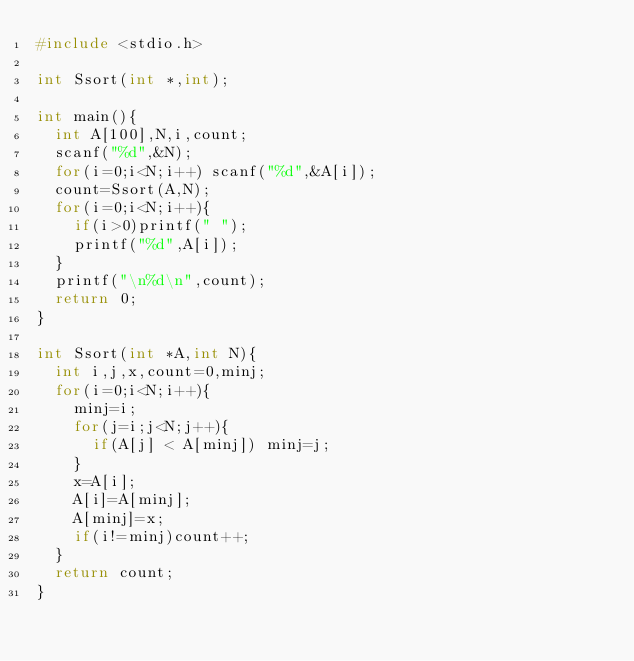Convert code to text. <code><loc_0><loc_0><loc_500><loc_500><_C_>#include <stdio.h>

int Ssort(int *,int);

int main(){
  int A[100],N,i,count;
  scanf("%d",&N);
  for(i=0;i<N;i++) scanf("%d",&A[i]);
  count=Ssort(A,N);
  for(i=0;i<N;i++){
    if(i>0)printf(" ");
    printf("%d",A[i]);
  }
  printf("\n%d\n",count);
  return 0;
}

int Ssort(int *A,int N){
  int i,j,x,count=0,minj;
  for(i=0;i<N;i++){
    minj=i;
    for(j=i;j<N;j++){
      if(A[j] < A[minj]) minj=j;
    }
    x=A[i];
    A[i]=A[minj];
    A[minj]=x;
    if(i!=minj)count++;
  }
  return count;
}

</code> 